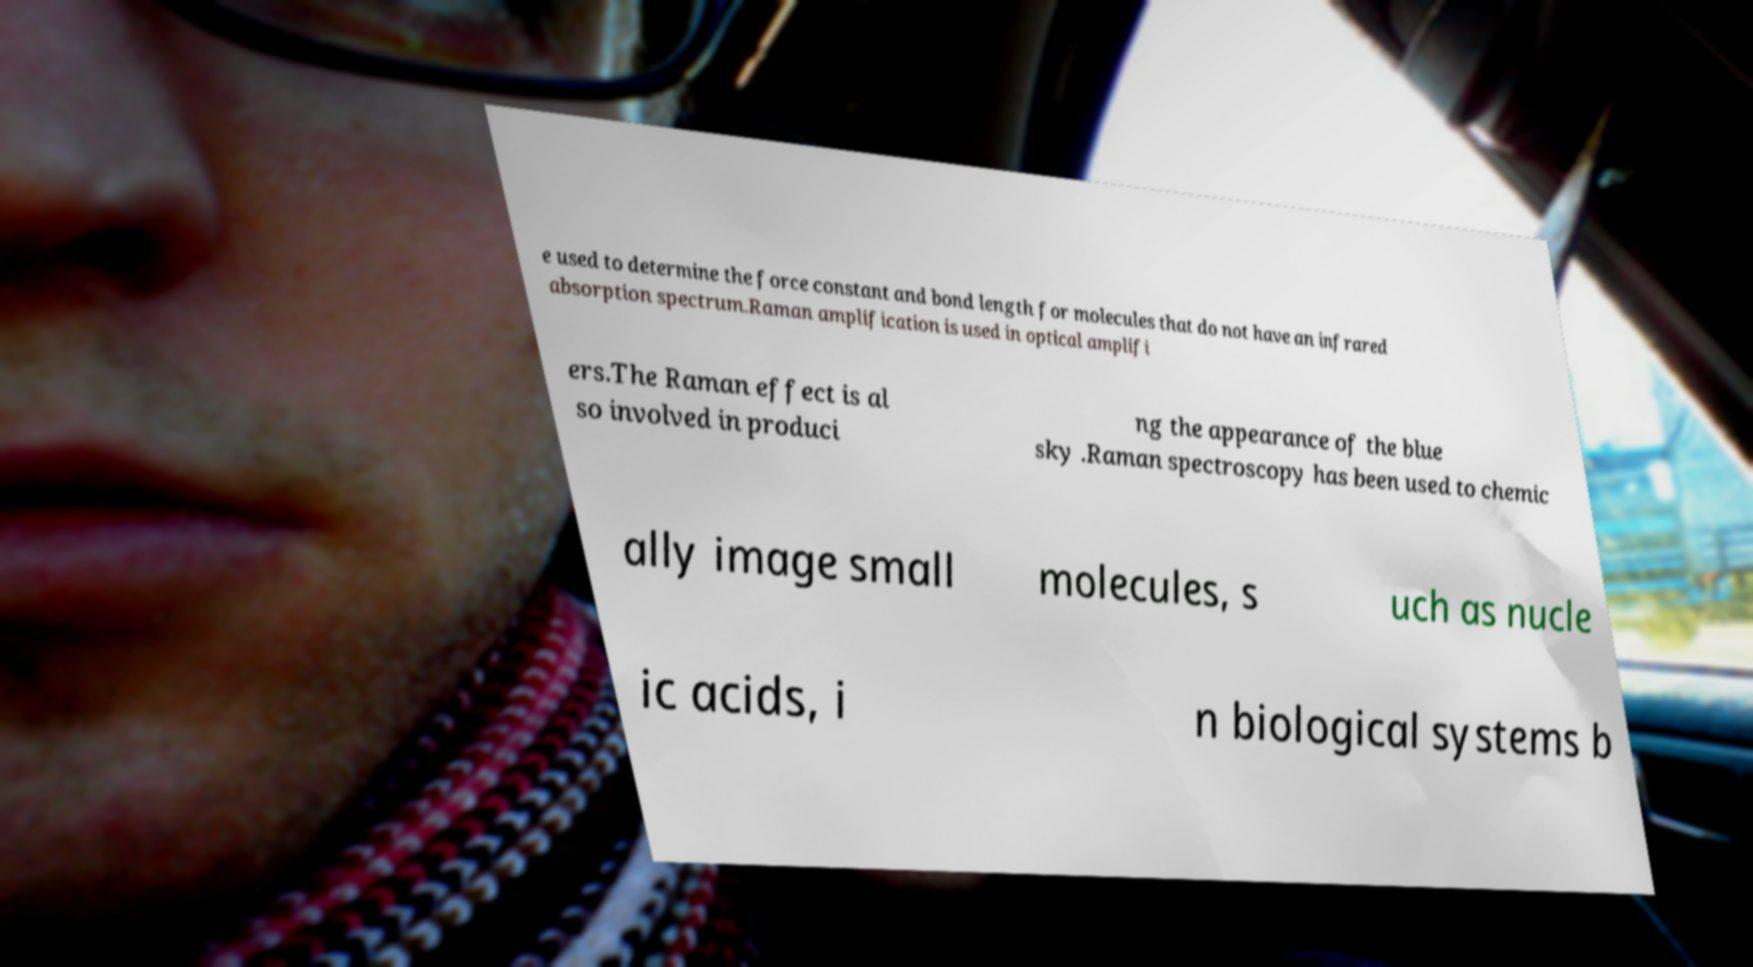For documentation purposes, I need the text within this image transcribed. Could you provide that? e used to determine the force constant and bond length for molecules that do not have an infrared absorption spectrum.Raman amplification is used in optical amplifi ers.The Raman effect is al so involved in produci ng the appearance of the blue sky .Raman spectroscopy has been used to chemic ally image small molecules, s uch as nucle ic acids, i n biological systems b 